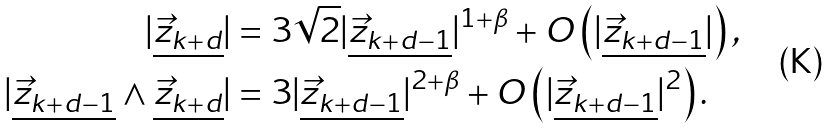<formula> <loc_0><loc_0><loc_500><loc_500>| \underline { \vec { z } _ { k + d } } | & = 3 \sqrt { 2 } | \underline { \vec { z } _ { k + d - 1 } } | ^ { 1 + \beta } + O \left ( | \underline { \vec { z } _ { k + d - 1 } } | \right ) , \\ | \underline { \vec { z } _ { k + d - 1 } } \wedge \underline { \vec { z } _ { k + d } } | & = 3 | \underline { \vec { z } _ { k + d - 1 } } | ^ { 2 + \beta } + O \left ( | \underline { \vec { z } _ { k + d - 1 } } | ^ { 2 } \right ) .</formula> 